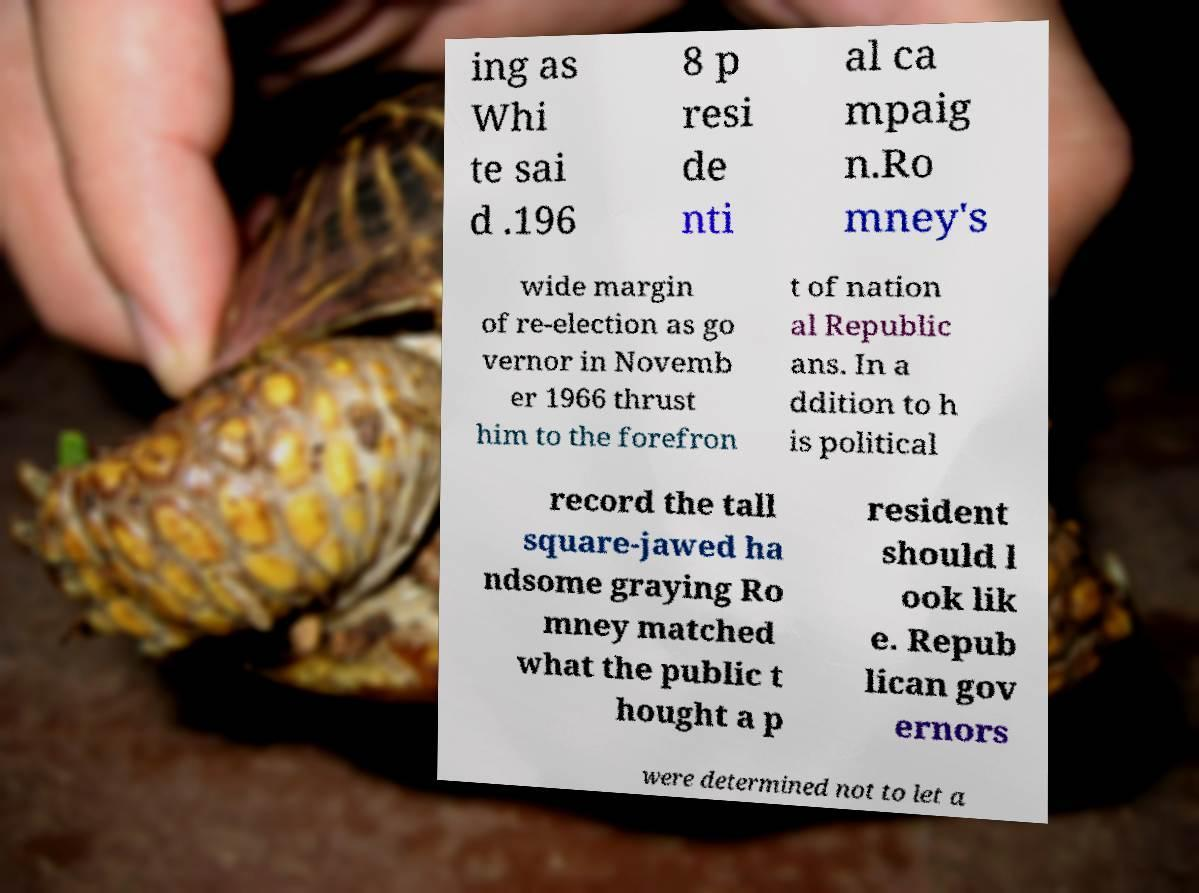Can you read and provide the text displayed in the image?This photo seems to have some interesting text. Can you extract and type it out for me? ing as Whi te sai d .196 8 p resi de nti al ca mpaig n.Ro mney's wide margin of re-election as go vernor in Novemb er 1966 thrust him to the forefron t of nation al Republic ans. In a ddition to h is political record the tall square-jawed ha ndsome graying Ro mney matched what the public t hought a p resident should l ook lik e. Repub lican gov ernors were determined not to let a 